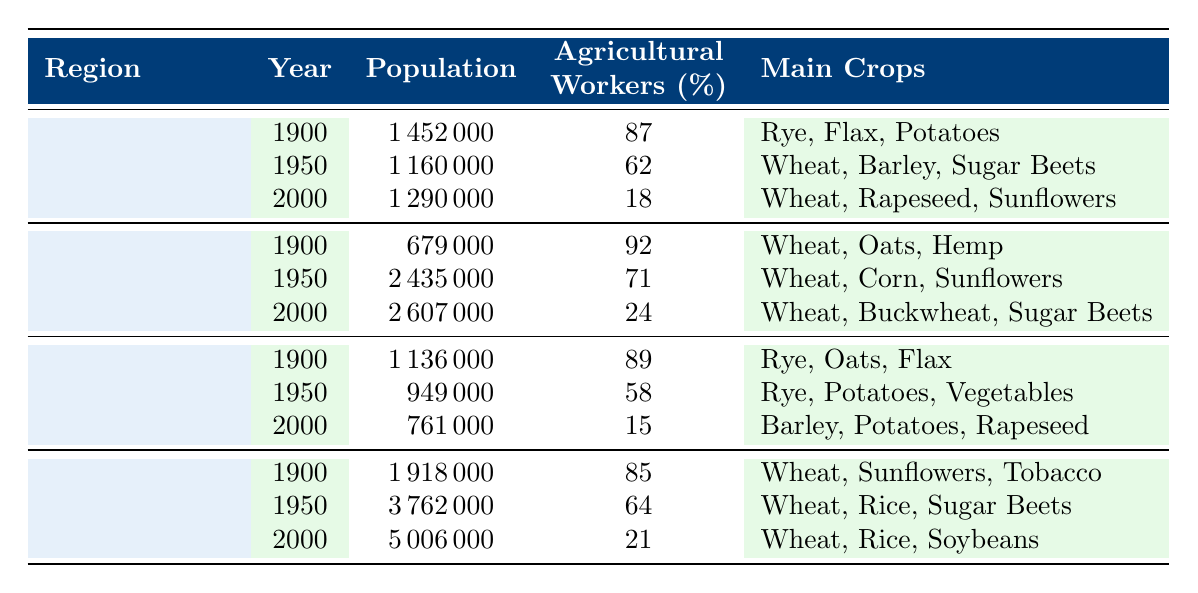What was the population of Vologda Oblast in the year 1900? In the table, we can see that for the region Vologda Oblast, the population in the year 1900 is listed under that year. The value is 1,452,000.
Answer: 1,452,000 What percentage of agricultural workers were there in Krasnodar Krai in 1950? Looking at Krasnodar Krai, the table indicates that in 1950, the percentage of agricultural workers is 64%.
Answer: 64% Which region had the highest population in the year 2000? By comparing the populations for the year 2000 across all regions in the table, we find that Krasnodar Krai has the highest population at 5,006,000.
Answer: Krasnodar Krai How many agricultural workers (as a percentage) were there in Altai Krai in the year 1900? According to the table, Altai Krai had 92% of its population as agricultural workers in 1900.
Answer: 92% What is the difference in population for Pskov Oblast from 1900 to 2000? For Pskov Oblast, the population in 1900 was 1,136,000, and in 2000 it was 761,000. The difference is calculated as 1,136,000 - 761,000, which equals 375,000.
Answer: 375,000 What was the percentage decrease of agricultural workers in Vologda Oblast from 1900 to 2000? The percentage of agricultural workers in Vologda Oblast decreased from 87% in 1900 to 18% in 2000. The decrease is 87% - 18% = 69%.
Answer: 69% Which main crop was common in all years for Krasnodar Krai? In the table, under Krasnodar Krai, the main crop for all years listed (1900, 1950, and 2000) is wheat.
Answer: Wheat What region had the smallest population in 1950? The table shows that Pskov Oblast had the smallest population in 1950 at 949,000 when compared to other regions.
Answer: Pskov Oblast What is the average percentage of agricultural workers in Vologda Oblast over the years presented? The percentages of agricultural workers in Vologda Oblast are 87%, 62%, and 18% for the years 1900, 1950, and 2000 respectively. The average is calculated as (87 + 62 + 18) / 3 = 55.67%.
Answer: 55.67% Did the population of Altai Krai increase or decrease from 1900 to 2000? In the table, we see that Altai Krai had a population of 679,000 in 1900 and 2,607,000 in 2000, indicating an increase.
Answer: Increase 